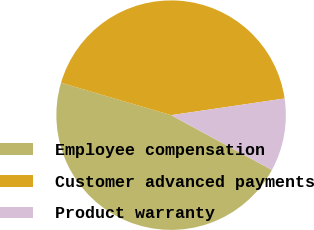Convert chart to OTSL. <chart><loc_0><loc_0><loc_500><loc_500><pie_chart><fcel>Employee compensation<fcel>Customer advanced payments<fcel>Product warranty<nl><fcel>46.63%<fcel>43.12%<fcel>10.25%<nl></chart> 